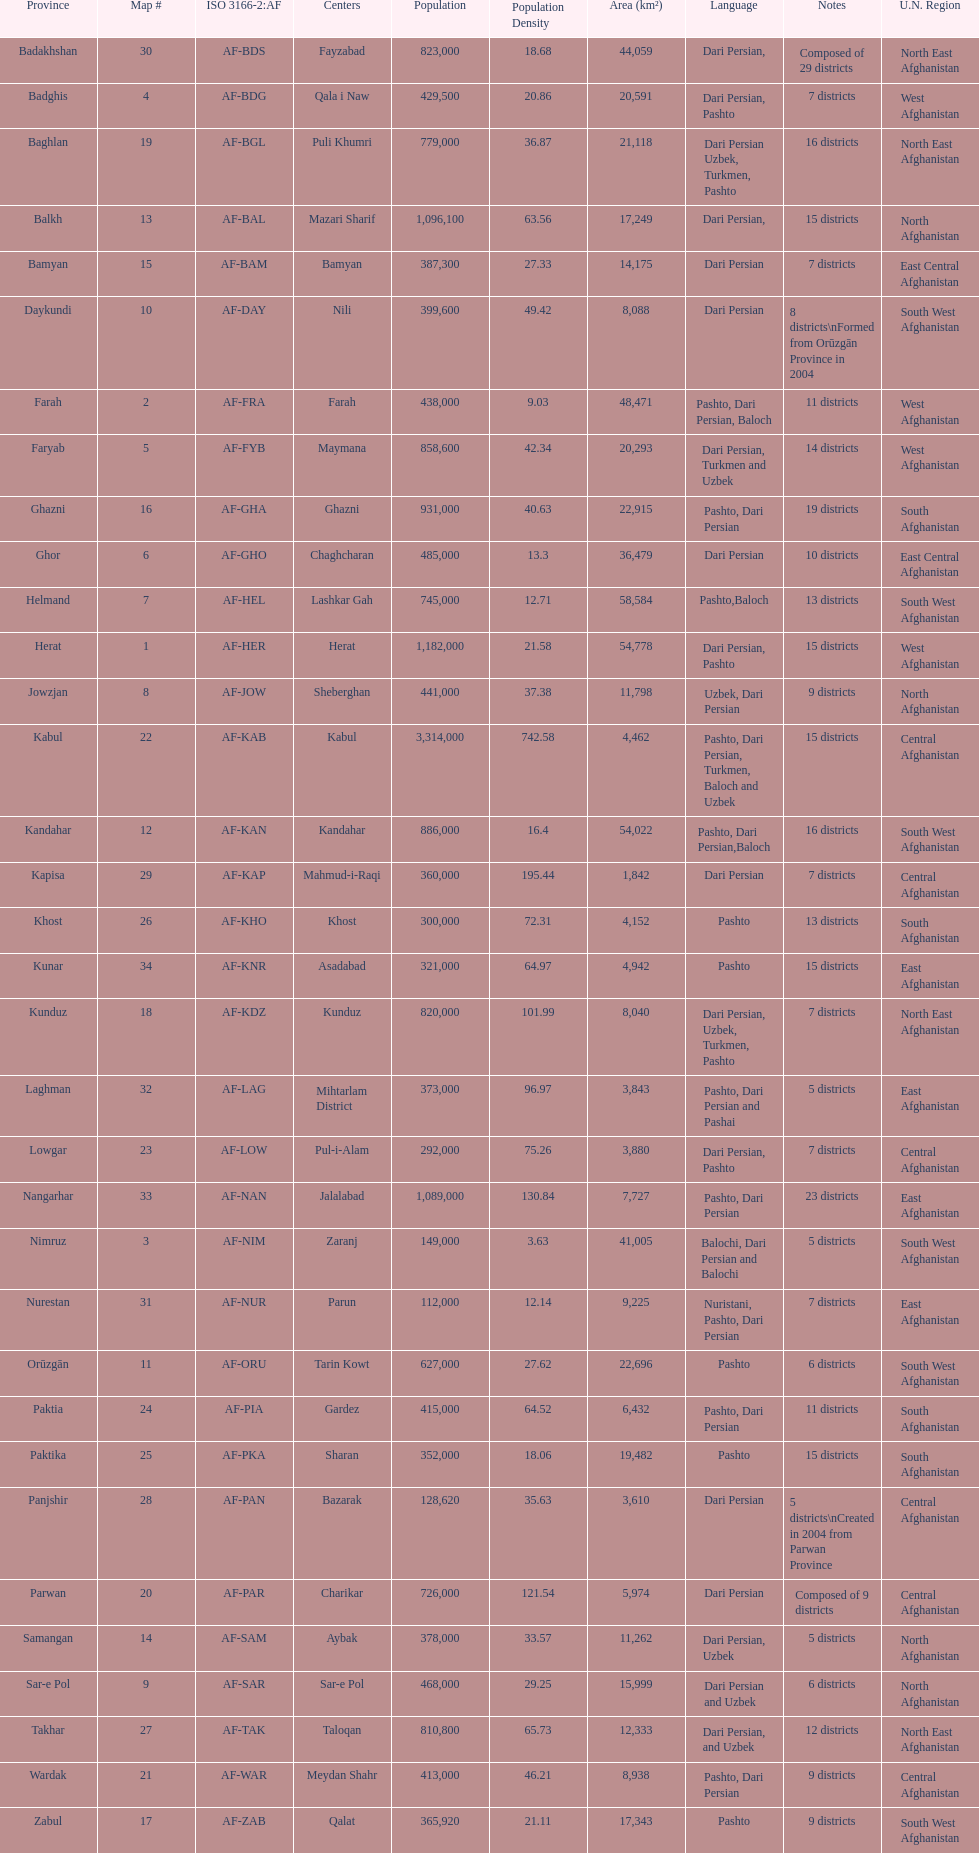How many provinces in afghanistan speak dari persian? 28. Could you parse the entire table? {'header': ['Province', 'Map #', 'ISO 3166-2:AF', 'Centers', 'Population', 'Population Density', 'Area (km²)', 'Language', 'Notes', 'U.N. Region'], 'rows': [['Badakhshan', '30', 'AF-BDS', 'Fayzabad', '823,000', '18.68', '44,059', 'Dari Persian,', 'Composed of 29 districts', 'North East Afghanistan'], ['Badghis', '4', 'AF-BDG', 'Qala i Naw', '429,500', '20.86', '20,591', 'Dari Persian, Pashto', '7 districts', 'West Afghanistan'], ['Baghlan', '19', 'AF-BGL', 'Puli Khumri', '779,000', '36.87', '21,118', 'Dari Persian Uzbek, Turkmen, Pashto', '16 districts', 'North East Afghanistan'], ['Balkh', '13', 'AF-BAL', 'Mazari Sharif', '1,096,100', '63.56', '17,249', 'Dari Persian,', '15 districts', 'North Afghanistan'], ['Bamyan', '15', 'AF-BAM', 'Bamyan', '387,300', '27.33', '14,175', 'Dari Persian', '7 districts', 'East Central Afghanistan'], ['Daykundi', '10', 'AF-DAY', 'Nili', '399,600', '49.42', '8,088', 'Dari Persian', '8 districts\\nFormed from Orūzgān Province in 2004', 'South West Afghanistan'], ['Farah', '2', 'AF-FRA', 'Farah', '438,000', '9.03', '48,471', 'Pashto, Dari Persian, Baloch', '11 districts', 'West Afghanistan'], ['Faryab', '5', 'AF-FYB', 'Maymana', '858,600', '42.34', '20,293', 'Dari Persian, Turkmen and Uzbek', '14 districts', 'West Afghanistan'], ['Ghazni', '16', 'AF-GHA', 'Ghazni', '931,000', '40.63', '22,915', 'Pashto, Dari Persian', '19 districts', 'South Afghanistan'], ['Ghor', '6', 'AF-GHO', 'Chaghcharan', '485,000', '13.3', '36,479', 'Dari Persian', '10 districts', 'East Central Afghanistan'], ['Helmand', '7', 'AF-HEL', 'Lashkar Gah', '745,000', '12.71', '58,584', 'Pashto,Baloch', '13 districts', 'South West Afghanistan'], ['Herat', '1', 'AF-HER', 'Herat', '1,182,000', '21.58', '54,778', 'Dari Persian, Pashto', '15 districts', 'West Afghanistan'], ['Jowzjan', '8', 'AF-JOW', 'Sheberghan', '441,000', '37.38', '11,798', 'Uzbek, Dari Persian', '9 districts', 'North Afghanistan'], ['Kabul', '22', 'AF-KAB', 'Kabul', '3,314,000', '742.58', '4,462', 'Pashto, Dari Persian, Turkmen, Baloch and Uzbek', '15 districts', 'Central Afghanistan'], ['Kandahar', '12', 'AF-KAN', 'Kandahar', '886,000', '16.4', '54,022', 'Pashto, Dari Persian,Baloch', '16 districts', 'South West Afghanistan'], ['Kapisa', '29', 'AF-KAP', 'Mahmud-i-Raqi', '360,000', '195.44', '1,842', 'Dari Persian', '7 districts', 'Central Afghanistan'], ['Khost', '26', 'AF-KHO', 'Khost', '300,000', '72.31', '4,152', 'Pashto', '13 districts', 'South Afghanistan'], ['Kunar', '34', 'AF-KNR', 'Asadabad', '321,000', '64.97', '4,942', 'Pashto', '15 districts', 'East Afghanistan'], ['Kunduz', '18', 'AF-KDZ', 'Kunduz', '820,000', '101.99', '8,040', 'Dari Persian, Uzbek, Turkmen, Pashto', '7 districts', 'North East Afghanistan'], ['Laghman', '32', 'AF-LAG', 'Mihtarlam District', '373,000', '96.97', '3,843', 'Pashto, Dari Persian and Pashai', '5 districts', 'East Afghanistan'], ['Lowgar', '23', 'AF-LOW', 'Pul-i-Alam', '292,000', '75.26', '3,880', 'Dari Persian, Pashto', '7 districts', 'Central Afghanistan'], ['Nangarhar', '33', 'AF-NAN', 'Jalalabad', '1,089,000', '130.84', '7,727', 'Pashto, Dari Persian', '23 districts', 'East Afghanistan'], ['Nimruz', '3', 'AF-NIM', 'Zaranj', '149,000', '3.63', '41,005', 'Balochi, Dari Persian and Balochi', '5 districts', 'South West Afghanistan'], ['Nurestan', '31', 'AF-NUR', 'Parun', '112,000', '12.14', '9,225', 'Nuristani, Pashto, Dari Persian', '7 districts', 'East Afghanistan'], ['Orūzgān', '11', 'AF-ORU', 'Tarin Kowt', '627,000', '27.62', '22,696', 'Pashto', '6 districts', 'South West Afghanistan'], ['Paktia', '24', 'AF-PIA', 'Gardez', '415,000', '64.52', '6,432', 'Pashto, Dari Persian', '11 districts', 'South Afghanistan'], ['Paktika', '25', 'AF-PKA', 'Sharan', '352,000', '18.06', '19,482', 'Pashto', '15 districts', 'South Afghanistan'], ['Panjshir', '28', 'AF-PAN', 'Bazarak', '128,620', '35.63', '3,610', 'Dari Persian', '5 districts\\nCreated in 2004 from Parwan Province', 'Central Afghanistan'], ['Parwan', '20', 'AF-PAR', 'Charikar', '726,000', '121.54', '5,974', 'Dari Persian', 'Composed of 9 districts', 'Central Afghanistan'], ['Samangan', '14', 'AF-SAM', 'Aybak', '378,000', '33.57', '11,262', 'Dari Persian, Uzbek', '5 districts', 'North Afghanistan'], ['Sar-e Pol', '9', 'AF-SAR', 'Sar-e Pol', '468,000', '29.25', '15,999', 'Dari Persian and Uzbek', '6 districts', 'North Afghanistan'], ['Takhar', '27', 'AF-TAK', 'Taloqan', '810,800', '65.73', '12,333', 'Dari Persian, and Uzbek', '12 districts', 'North East Afghanistan'], ['Wardak', '21', 'AF-WAR', 'Meydan Shahr', '413,000', '46.21', '8,938', 'Pashto, Dari Persian', '9 districts', 'Central Afghanistan'], ['Zabul', '17', 'AF-ZAB', 'Qalat', '365,920', '21.11', '17,343', 'Pashto', '9 districts', 'South West Afghanistan']]} 